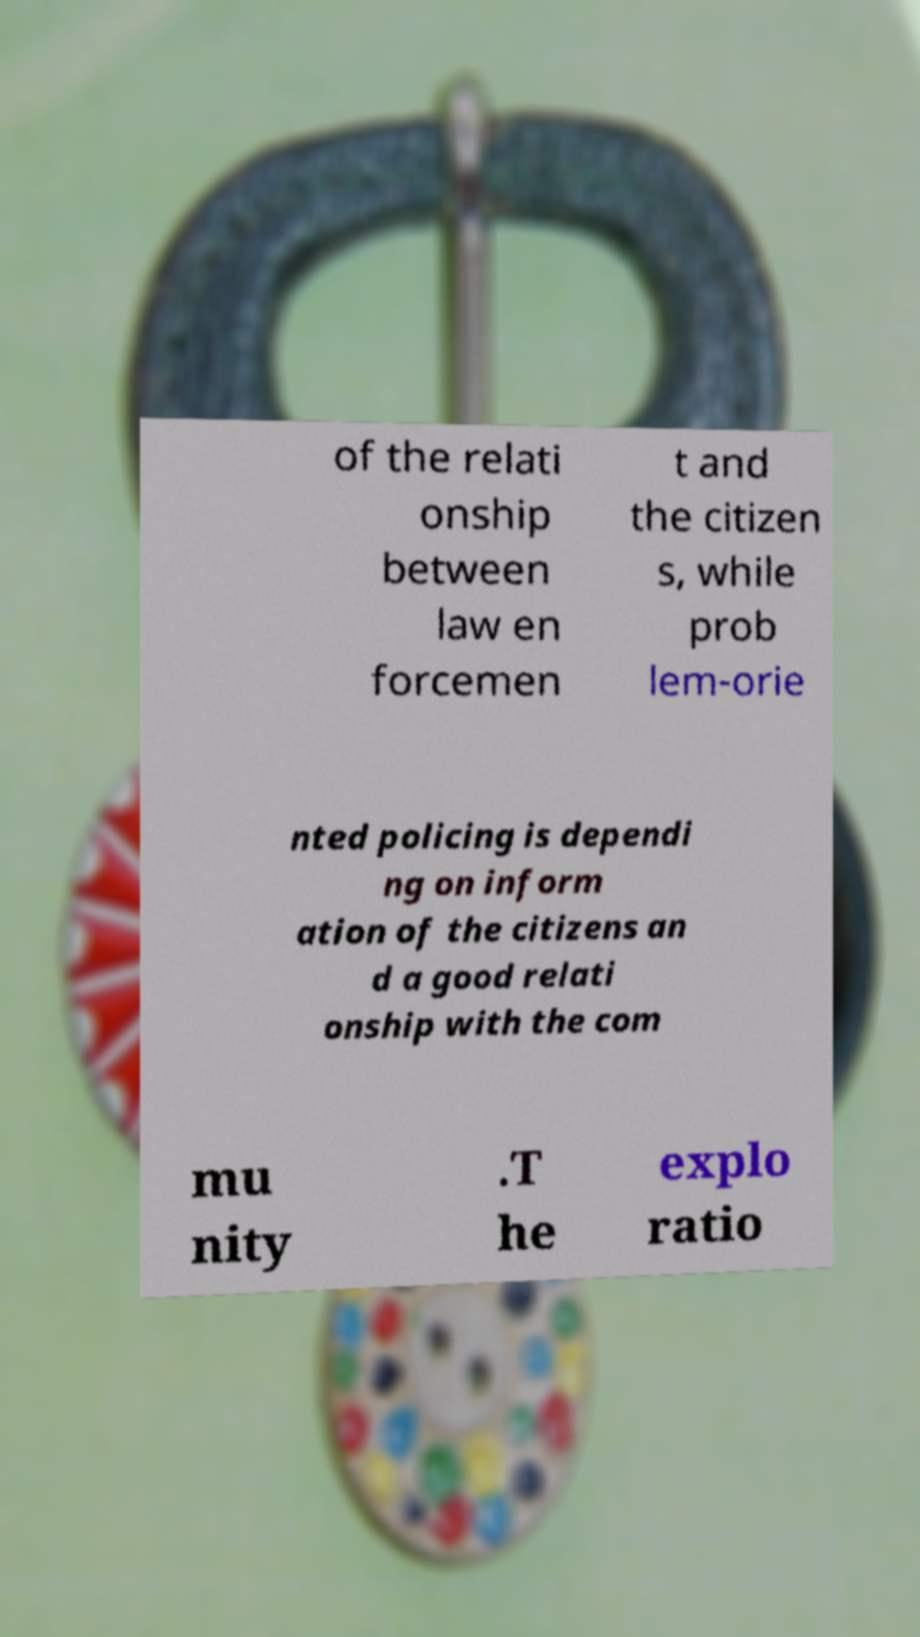Please identify and transcribe the text found in this image. of the relati onship between law en forcemen t and the citizen s, while prob lem-orie nted policing is dependi ng on inform ation of the citizens an d a good relati onship with the com mu nity .T he explo ratio 